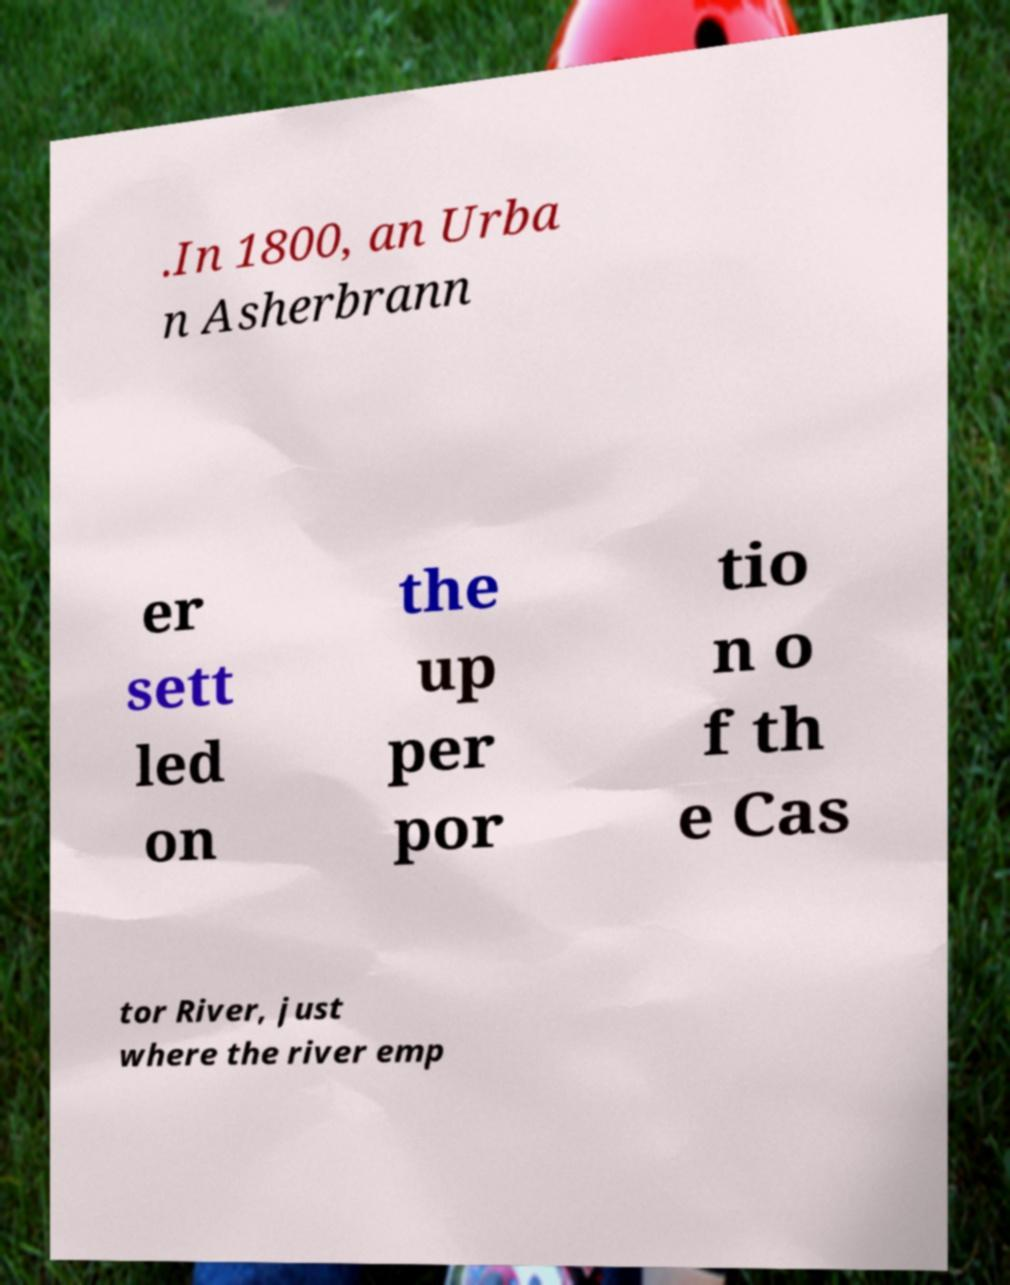I need the written content from this picture converted into text. Can you do that? .In 1800, an Urba n Asherbrann er sett led on the up per por tio n o f th e Cas tor River, just where the river emp 